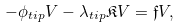Convert formula to latex. <formula><loc_0><loc_0><loc_500><loc_500>- \phi _ { t i p } V - \lambda _ { t i p } \mathfrak { K } V = \mathfrak { f } V ,</formula> 